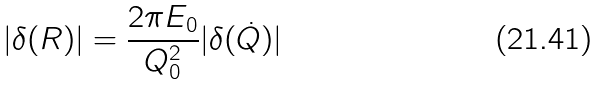Convert formula to latex. <formula><loc_0><loc_0><loc_500><loc_500>| \delta ( R ) | = \frac { 2 \pi E _ { 0 } } { Q _ { 0 } ^ { 2 } } | \delta ( \dot { Q } ) |</formula> 